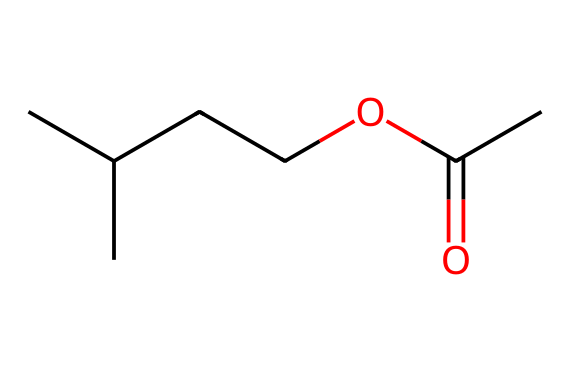What is the main functional group in isoamyl acetate? The structure shows a carbonyl group (C=O) next to an oxygen atom (O), indicating the presence of an ester functional group.
Answer: ester How many carbon atoms are present in isoamyl acetate? By counting the carbon atoms in the structure, we find 5 carbon atoms from the isoamyl part and 1 carbon atom from the carbonyl, totaling 6.
Answer: six What type of chemical reaction is used to produce isoamyl acetate? Isoamyl acetate is produced through a condensation reaction (esterification) between an alcohol (isoamyl alcohol) and a carboxylic acid (acetic acid).
Answer: esterification How many double bonds are in the structure of isoamyl acetate? Examining the structure reveals there is one double bond present in the carbonyl (C=O) of the ester functional group; the rest of the bonds are single.
Answer: one What is the impact of the isoamyl group on the scent of isoamyl acetate? The isoamyl group contributes to the banana-like aroma associated with this ester, which is characteristic of its fruity scent profile.
Answer: fruity scent Which atoms influence the polar nature of isoamyl acetate? The presence of the carbonyl group (C=O) makes the molecule polar due to the significant difference in electronegativity between carbon and oxygen, influencing the overall polarity.
Answer: carbonyl oxygen 